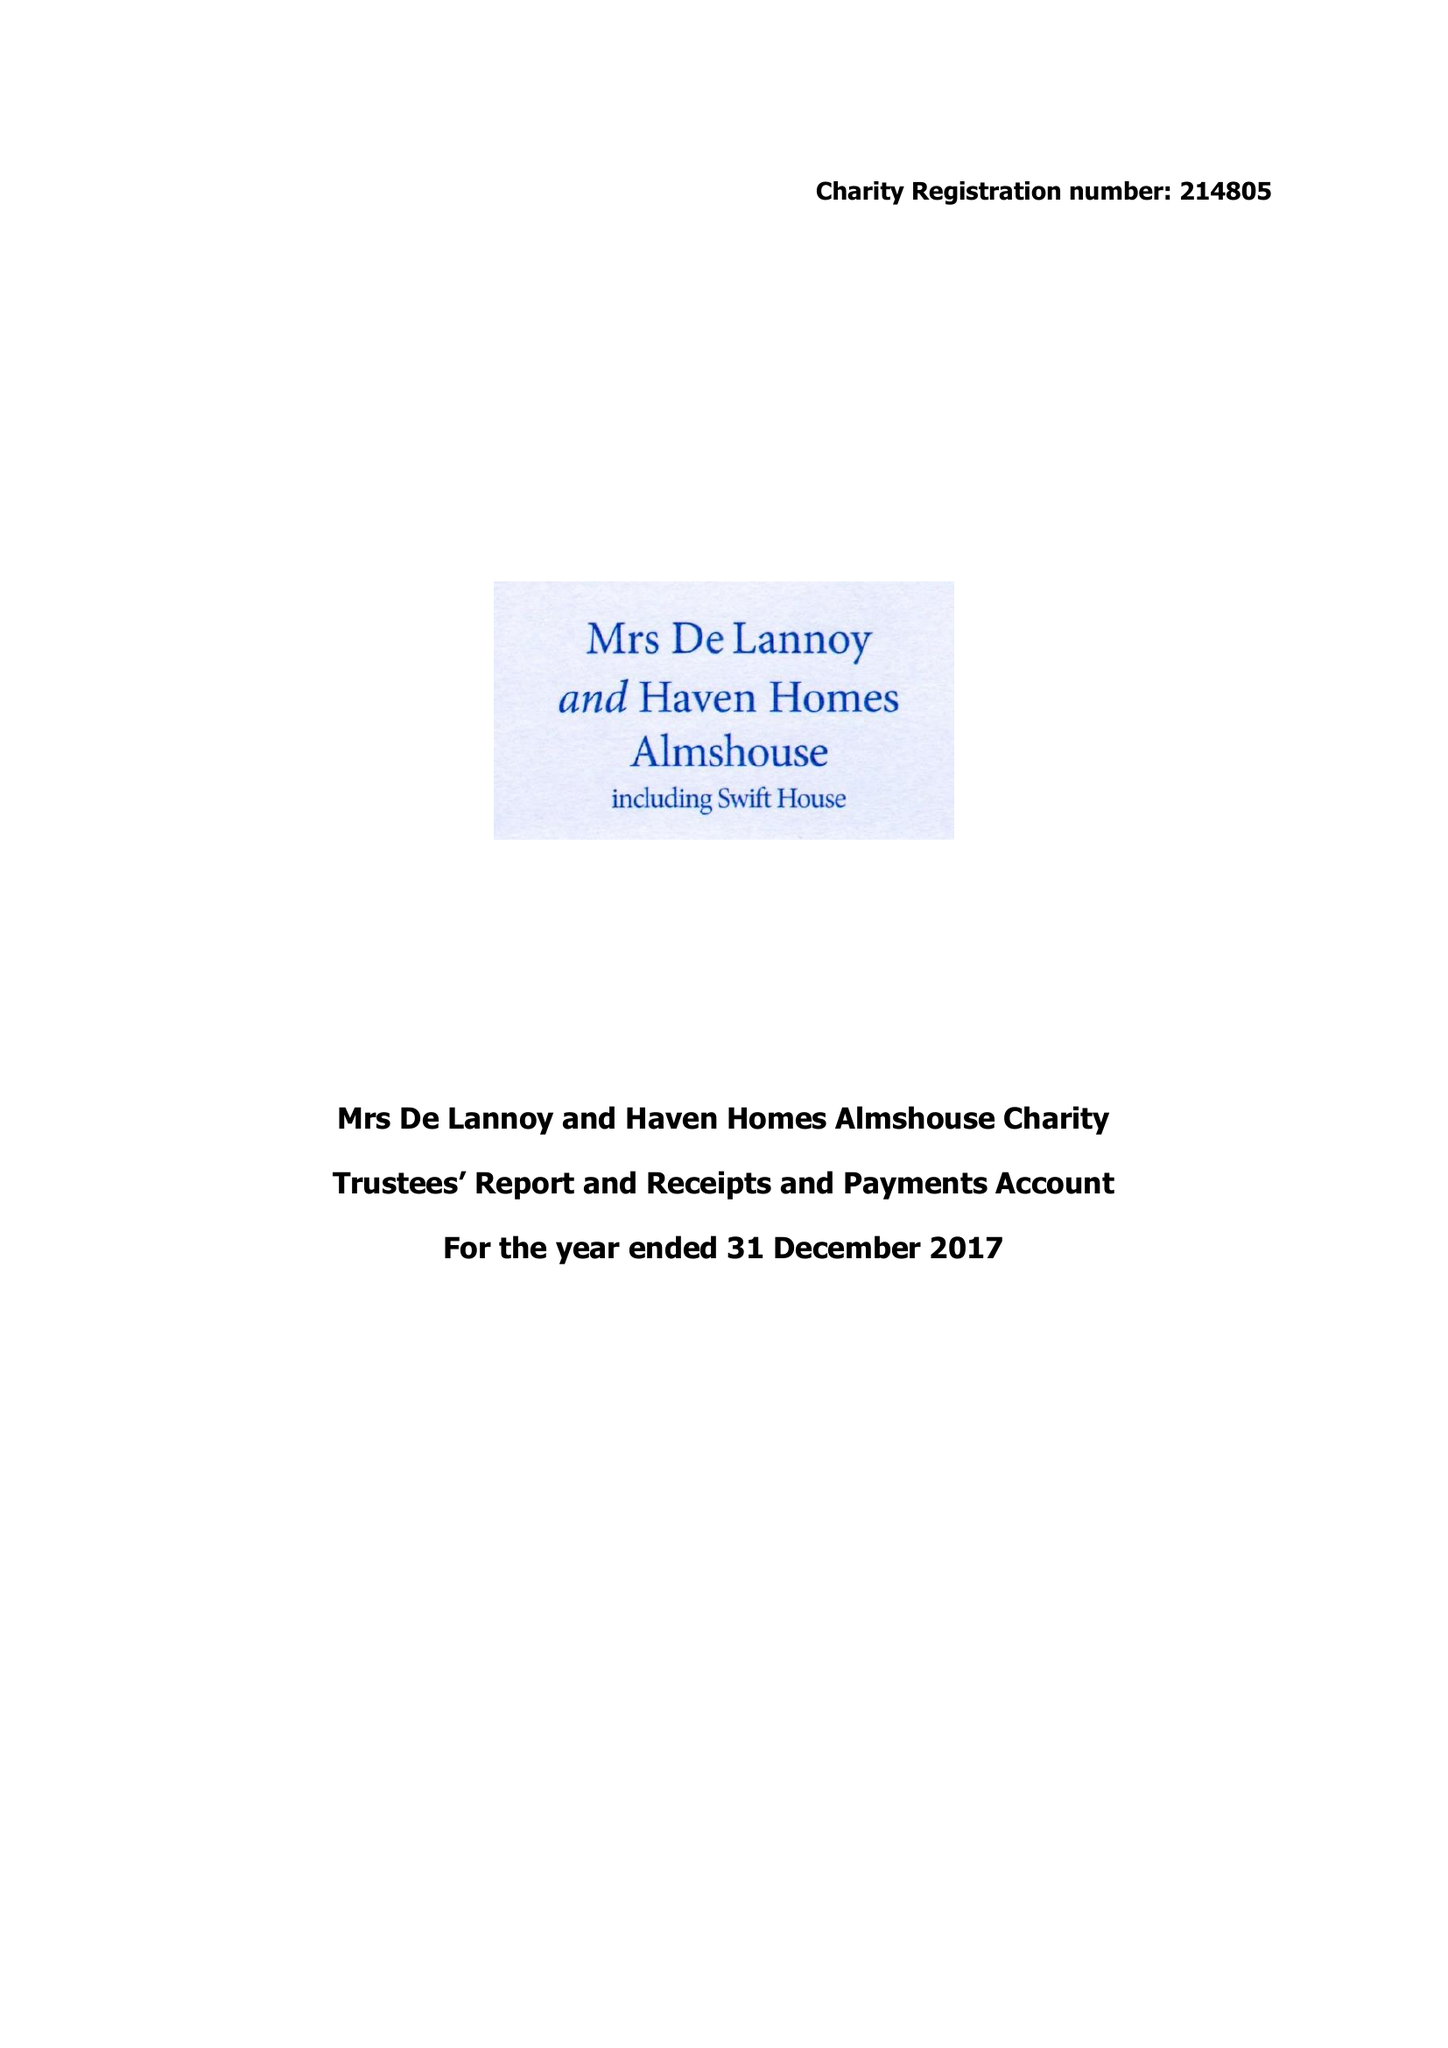What is the value for the income_annually_in_british_pounds?
Answer the question using a single word or phrase. 63716.00 